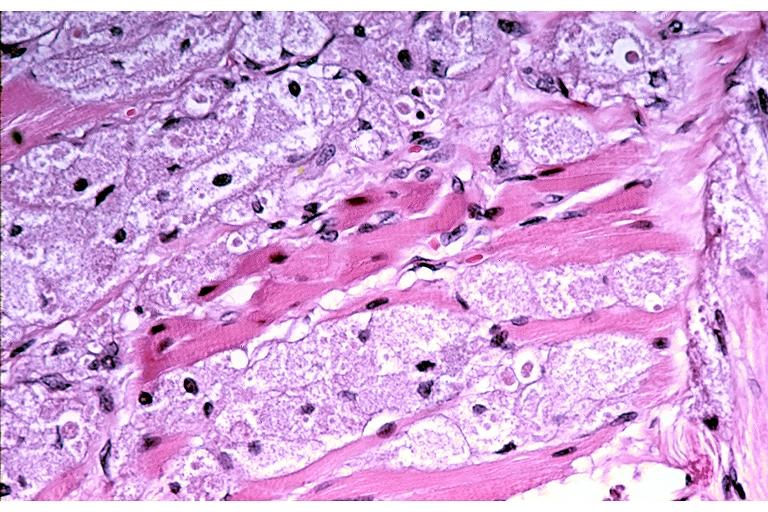s oral present?
Answer the question using a single word or phrase. Yes 